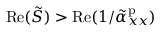Convert formula to latex. <formula><loc_0><loc_0><loc_500><loc_500>R e ( \tilde { S } ) > R e ( 1 / \tilde { \alpha } _ { x x } ^ { p } )</formula> 